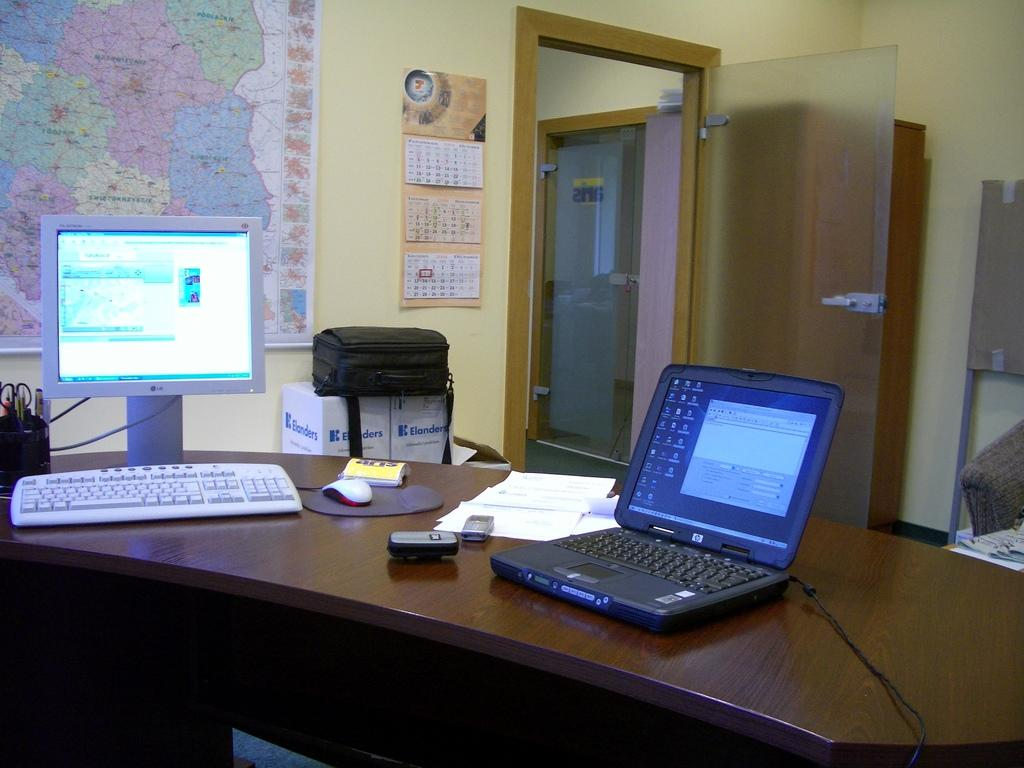What is placed on top of the table in the image? There are systems on top of the table in the image. What can be seen in the background of the image? There is a door and a world outline map in the background of the image. What type of scarf is draped over the world outline map in the image? There is no scarf present in the image; it only features a world outline map and a door in the background. 